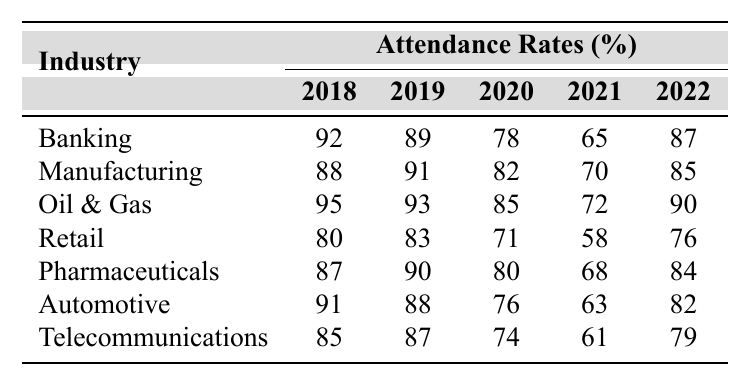What was the attendance rate for the Oil & Gas industry in 2020? From the table, we can find that the attendance rate for the Oil & Gas industry in 2020 is listed directly, which shows it as 85%.
Answer: 85% Which industry had the highest attendance rate in 2018? Looking at the table under the year 2018, we see that the Oil & Gas industry had the highest attendance rate at 95%.
Answer: Oil & Gas What was the average attendance rate for the Banking industry from 2018 to 2022? We sum the attendance rates for the Banking industry: 92 + 89 + 78 + 65 + 87 = 411. Then, dividing by the number of years (5) gives us an average of 411 / 5 = 82.2.
Answer: 82.2 Did the attendance rate for the Retail industry increase from 2018 to 2022? Analyzing the rates, we see the attendance rates for Retail in those years are 80, 83, 71, 58, and 76. Therefore, it decreased from 2018 to 2021 and then increased slightly in 2022. Thus, it did not show a consistent increase.
Answer: No What is the difference in attendance rates of the Pharmaceutical industry between 2018 and 2022? Checking the table, the attendance rate in 2018 is 87% and in 2022 is 84%. The difference is calculated as 87 - 84 = 3%.
Answer: 3% Which industry experienced the largest decline in attendance rates between 2020 and 2021? From analyzing the table, we note the attendance rates for each industry: Banking (78 to 65, a decline of 13), Manufacturing (82 to 70, a decline of 12), Oil & Gas (85 to 72, a decline of 13), Retail (71 to 58, a decline of 13), Pharmaceuticals (80 to 68, a decline of 12), Automotive (76 to 63, a decline of 13), and Telecommunications (74 to 61, a decline of 13). Several industries as observed had the same decline of 13%.
Answer: Multiple industries (Banking, Oil & Gas, Retail, Automotive, Telecommunications) Which industry's attendance rate showed the most improvement from 2021 to 2022? Reviewing the rates from 2021 to 2022, we see that the Banking industry improved from 65 to 87, which is an increase of 22%. The other industries had lower improvements: Manufacturing (70 to 85, an increase of 15%), Oil & Gas (72 to 90, an increase of 18%), Retail (58 to 76, an increase of 18%), Pharmaceuticals (68 to 84, an increase of 16%), Automotive (63 to 82, an increase of 19%), and Telecommunications (61 to 79, an increase of 18%). Therefore, Banking had the highest improvement.
Answer: Banking What was the attendance rate for the Telecommunications industry for all reported years, and how does it compare to the average attendance across all industries in 2021? For Telecommunications, the attendance rates over the years are 85, 87, 74, 61, and 79. In 2021, it was 61. To find the average attendance across all industries in 2021, we look at the rates: 65, 70, 72, 58, 68, 63, 61—which sums up to 66.71 for the average. Since 61 (Telecommunications in 2021) is below this average, it indicates poorer attendance in that year.
Answer: Below average What is the trend observed in attendance rates across the Manufacturing industry from 2018 to 2022? The attendance rates in Manufacturing over the years are 88, 91, 82, 70, and 85. The trend shows a decline from 2018 to 2021, with a rebound in 2022. Thus, it declined initially but improved last.
Answer: Decline then improvement 